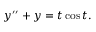<formula> <loc_0><loc_0><loc_500><loc_500>y ^ { \prime \prime } + y = t \cos t .</formula> 